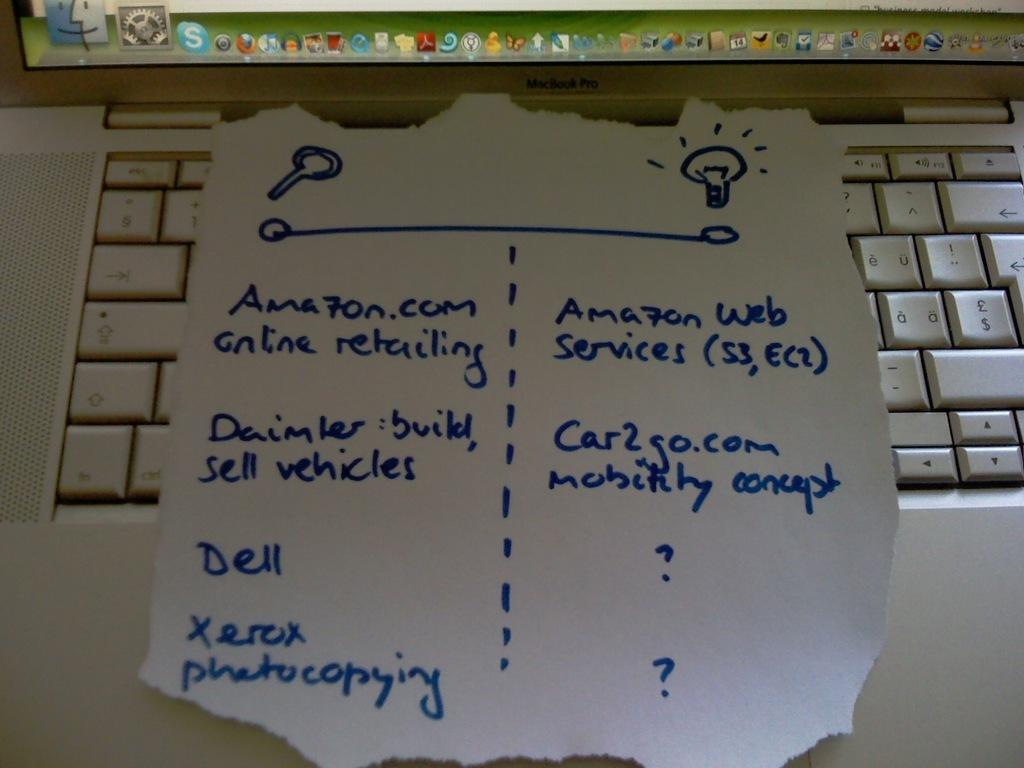<image>
Render a clear and concise summary of the photo. A blue, hand written list includes the Amazon website. 